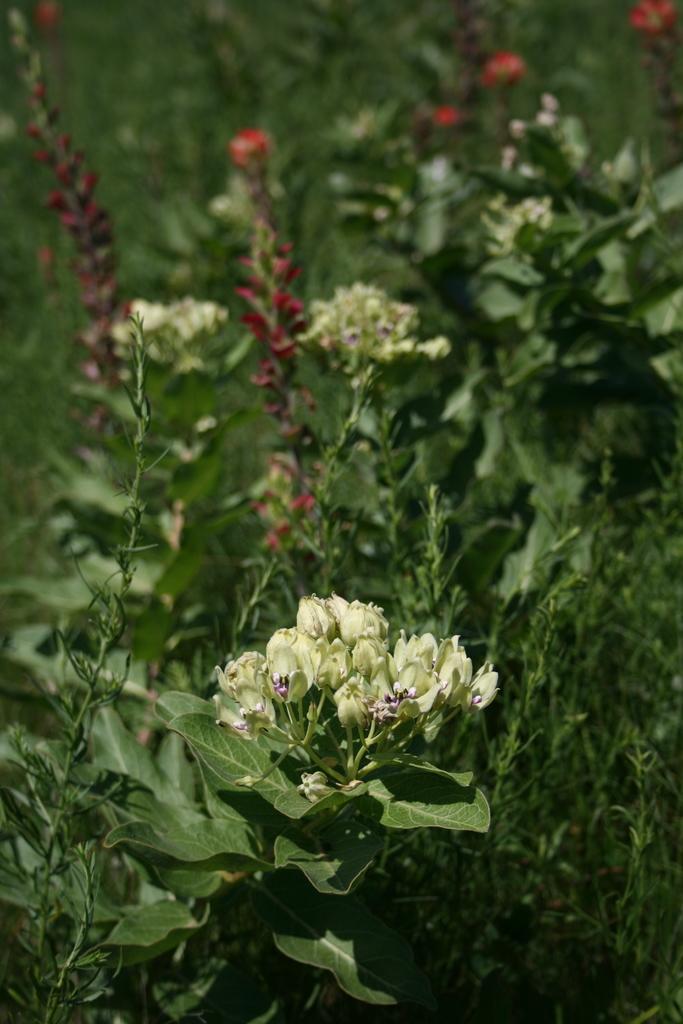Please provide a concise description of this image. In this image there are plants with colorful flowers. 